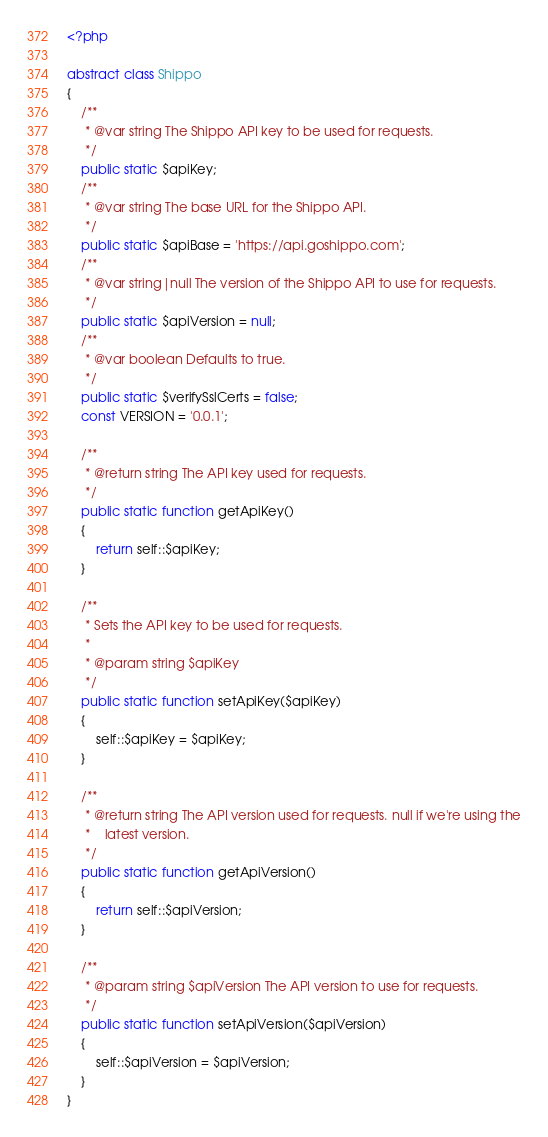Convert code to text. <code><loc_0><loc_0><loc_500><loc_500><_PHP_><?php

abstract class Shippo
{
    /**
     * @var string The Shippo API key to be used for requests. 
     */
    public static $apiKey;
    /**
     * @var string The base URL for the Shippo API.
     */
    public static $apiBase = 'https://api.goshippo.com';
    /**
     * @var string|null The version of the Shippo API to use for requests.
     */
    public static $apiVersion = null;
    /**
     * @var boolean Defaults to true.
     */
    public static $verifySslCerts = false;
    const VERSION = '0.0.1';
    
    /**
     * @return string The API key used for requests.
     */
    public static function getApiKey()
    {
        return self::$apiKey;
    }
    
    /**
     * Sets the API key to be used for requests.
     *
     * @param string $apiKey
     */
    public static function setApiKey($apiKey)
    {
        self::$apiKey = $apiKey;
    }
    
    /**
     * @return string The API version used for requests. null if we're using the
     *    latest version.
     */
    public static function getApiVersion()
    {
        return self::$apiVersion;
    }
    
    /**
     * @param string $apiVersion The API version to use for requests.
     */
    public static function setApiVersion($apiVersion)
    {
        self::$apiVersion = $apiVersion;
    }
}
</code> 